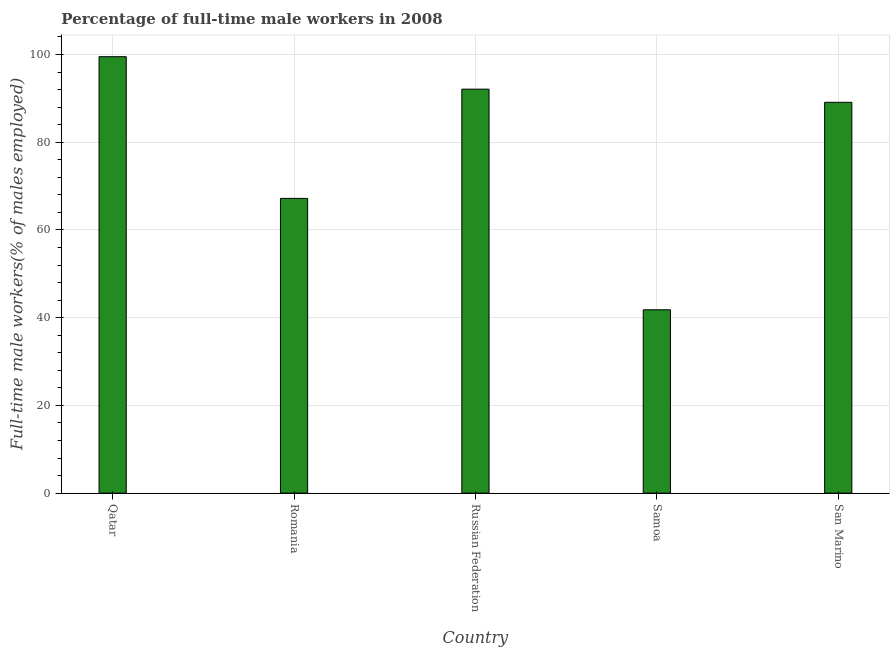Does the graph contain any zero values?
Your answer should be compact. No. What is the title of the graph?
Your response must be concise. Percentage of full-time male workers in 2008. What is the label or title of the X-axis?
Offer a terse response. Country. What is the label or title of the Y-axis?
Provide a succinct answer. Full-time male workers(% of males employed). What is the percentage of full-time male workers in Qatar?
Your answer should be compact. 99.5. Across all countries, what is the maximum percentage of full-time male workers?
Ensure brevity in your answer.  99.5. Across all countries, what is the minimum percentage of full-time male workers?
Your answer should be compact. 41.8. In which country was the percentage of full-time male workers maximum?
Your answer should be compact. Qatar. In which country was the percentage of full-time male workers minimum?
Your answer should be very brief. Samoa. What is the sum of the percentage of full-time male workers?
Make the answer very short. 389.7. What is the difference between the percentage of full-time male workers in Russian Federation and Samoa?
Keep it short and to the point. 50.3. What is the average percentage of full-time male workers per country?
Provide a succinct answer. 77.94. What is the median percentage of full-time male workers?
Provide a succinct answer. 89.1. What is the ratio of the percentage of full-time male workers in Samoa to that in San Marino?
Your answer should be compact. 0.47. What is the difference between the highest and the second highest percentage of full-time male workers?
Offer a very short reply. 7.4. What is the difference between the highest and the lowest percentage of full-time male workers?
Ensure brevity in your answer.  57.7. Are all the bars in the graph horizontal?
Ensure brevity in your answer.  No. How many countries are there in the graph?
Ensure brevity in your answer.  5. What is the difference between two consecutive major ticks on the Y-axis?
Offer a terse response. 20. What is the Full-time male workers(% of males employed) of Qatar?
Offer a terse response. 99.5. What is the Full-time male workers(% of males employed) of Romania?
Provide a short and direct response. 67.2. What is the Full-time male workers(% of males employed) in Russian Federation?
Your answer should be very brief. 92.1. What is the Full-time male workers(% of males employed) in Samoa?
Offer a terse response. 41.8. What is the Full-time male workers(% of males employed) in San Marino?
Provide a succinct answer. 89.1. What is the difference between the Full-time male workers(% of males employed) in Qatar and Romania?
Make the answer very short. 32.3. What is the difference between the Full-time male workers(% of males employed) in Qatar and Russian Federation?
Give a very brief answer. 7.4. What is the difference between the Full-time male workers(% of males employed) in Qatar and Samoa?
Offer a very short reply. 57.7. What is the difference between the Full-time male workers(% of males employed) in Romania and Russian Federation?
Give a very brief answer. -24.9. What is the difference between the Full-time male workers(% of males employed) in Romania and Samoa?
Ensure brevity in your answer.  25.4. What is the difference between the Full-time male workers(% of males employed) in Romania and San Marino?
Your answer should be compact. -21.9. What is the difference between the Full-time male workers(% of males employed) in Russian Federation and Samoa?
Your response must be concise. 50.3. What is the difference between the Full-time male workers(% of males employed) in Russian Federation and San Marino?
Provide a succinct answer. 3. What is the difference between the Full-time male workers(% of males employed) in Samoa and San Marino?
Offer a terse response. -47.3. What is the ratio of the Full-time male workers(% of males employed) in Qatar to that in Romania?
Give a very brief answer. 1.48. What is the ratio of the Full-time male workers(% of males employed) in Qatar to that in Samoa?
Your answer should be very brief. 2.38. What is the ratio of the Full-time male workers(% of males employed) in Qatar to that in San Marino?
Make the answer very short. 1.12. What is the ratio of the Full-time male workers(% of males employed) in Romania to that in Russian Federation?
Offer a terse response. 0.73. What is the ratio of the Full-time male workers(% of males employed) in Romania to that in Samoa?
Keep it short and to the point. 1.61. What is the ratio of the Full-time male workers(% of males employed) in Romania to that in San Marino?
Make the answer very short. 0.75. What is the ratio of the Full-time male workers(% of males employed) in Russian Federation to that in Samoa?
Offer a very short reply. 2.2. What is the ratio of the Full-time male workers(% of males employed) in Russian Federation to that in San Marino?
Keep it short and to the point. 1.03. What is the ratio of the Full-time male workers(% of males employed) in Samoa to that in San Marino?
Offer a terse response. 0.47. 